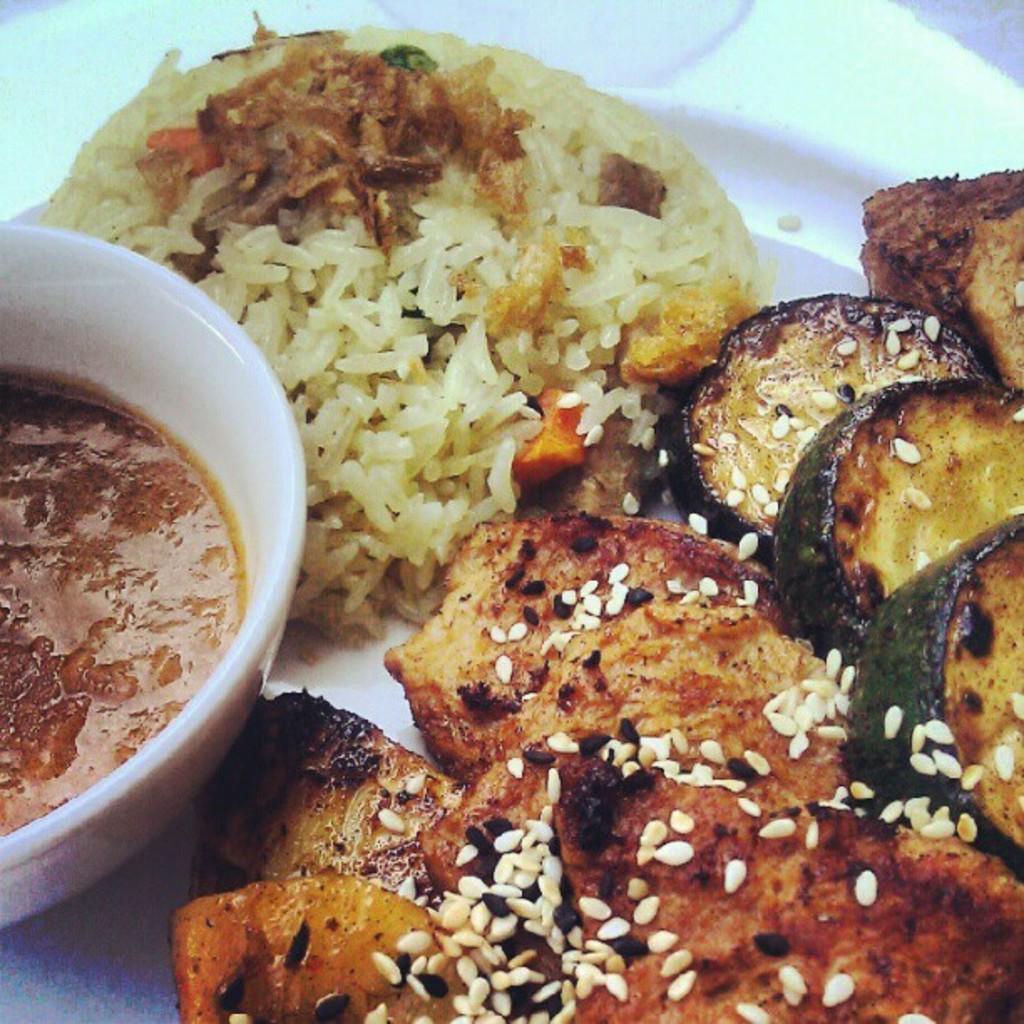Could you give a brief overview of what you see in this image? In this picture I can see food and a bowl in the plate. 